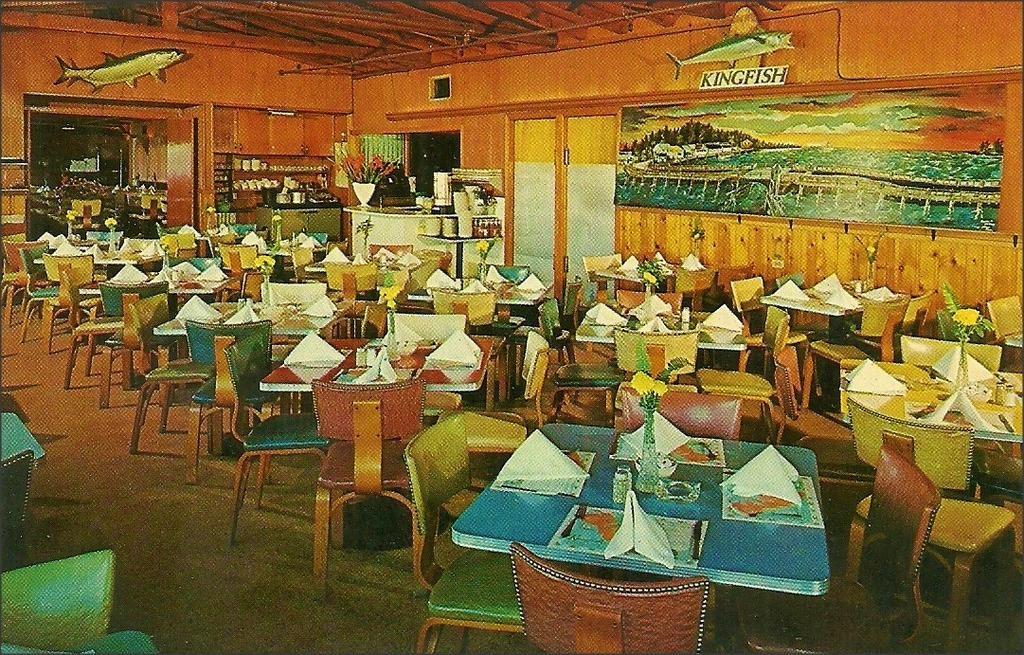In one or two sentences, can you explain what this image depicts? In this image I can see tables, chairs, flower vases, tissue papers on the tables. In the background I can see a wall, wall paintings, cabinet, cups, glasses in a shelf, doors and a rooftop. This image looks like an edited photo. 